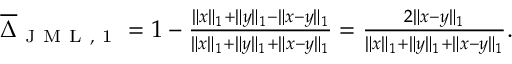<formula> <loc_0><loc_0><loc_500><loc_500>\begin{array} { r } { \overline { \Delta } _ { J M L , 1 } = 1 - \frac { \| x \| _ { 1 } + \| y \| _ { 1 } - \| x - y \| _ { 1 } } { \| x \| _ { 1 } + \| y \| _ { 1 } + \| x - y \| _ { 1 } } = \frac { 2 \| x - y \| _ { 1 } } { \| x \| _ { 1 } + \| y \| _ { 1 } + \| x - y \| _ { 1 } } . } \end{array}</formula> 